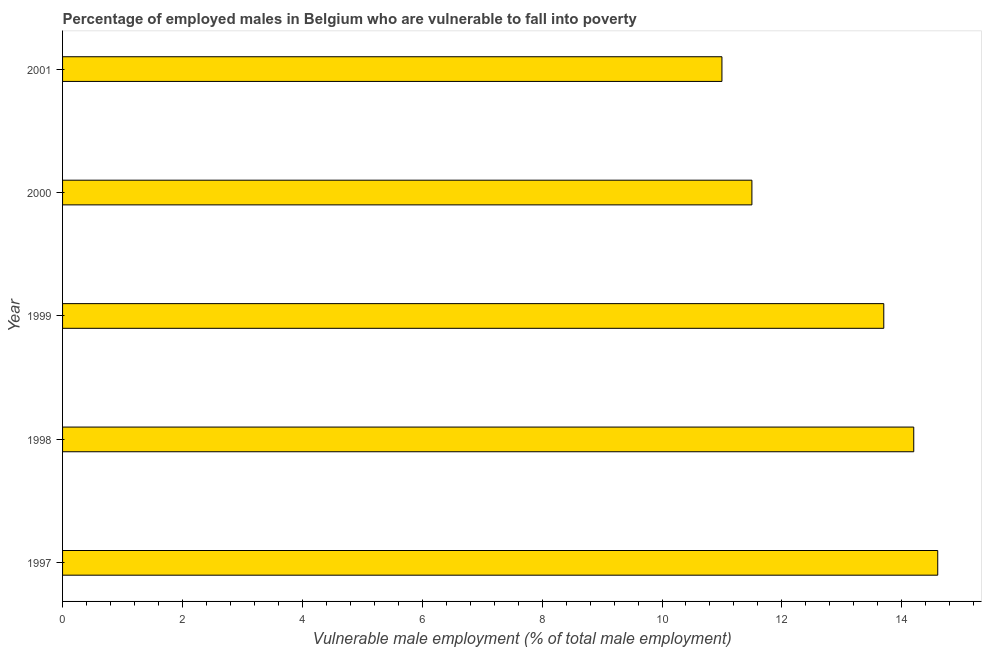Does the graph contain any zero values?
Your answer should be very brief. No. What is the title of the graph?
Your answer should be very brief. Percentage of employed males in Belgium who are vulnerable to fall into poverty. What is the label or title of the X-axis?
Provide a short and direct response. Vulnerable male employment (% of total male employment). What is the label or title of the Y-axis?
Provide a short and direct response. Year. What is the percentage of employed males who are vulnerable to fall into poverty in 2001?
Give a very brief answer. 11. Across all years, what is the maximum percentage of employed males who are vulnerable to fall into poverty?
Make the answer very short. 14.6. In which year was the percentage of employed males who are vulnerable to fall into poverty minimum?
Ensure brevity in your answer.  2001. What is the sum of the percentage of employed males who are vulnerable to fall into poverty?
Your answer should be very brief. 65. What is the difference between the percentage of employed males who are vulnerable to fall into poverty in 2000 and 2001?
Provide a short and direct response. 0.5. What is the average percentage of employed males who are vulnerable to fall into poverty per year?
Provide a succinct answer. 13. What is the median percentage of employed males who are vulnerable to fall into poverty?
Your response must be concise. 13.7. In how many years, is the percentage of employed males who are vulnerable to fall into poverty greater than 8 %?
Your answer should be very brief. 5. What is the ratio of the percentage of employed males who are vulnerable to fall into poverty in 1997 to that in 1999?
Give a very brief answer. 1.07. Is the difference between the percentage of employed males who are vulnerable to fall into poverty in 1998 and 1999 greater than the difference between any two years?
Keep it short and to the point. No. What is the difference between the highest and the second highest percentage of employed males who are vulnerable to fall into poverty?
Offer a very short reply. 0.4. Is the sum of the percentage of employed males who are vulnerable to fall into poverty in 1997 and 2000 greater than the maximum percentage of employed males who are vulnerable to fall into poverty across all years?
Make the answer very short. Yes. In how many years, is the percentage of employed males who are vulnerable to fall into poverty greater than the average percentage of employed males who are vulnerable to fall into poverty taken over all years?
Your answer should be very brief. 3. Are all the bars in the graph horizontal?
Provide a short and direct response. Yes. What is the Vulnerable male employment (% of total male employment) of 1997?
Your answer should be very brief. 14.6. What is the Vulnerable male employment (% of total male employment) in 1998?
Your answer should be very brief. 14.2. What is the Vulnerable male employment (% of total male employment) in 1999?
Offer a terse response. 13.7. What is the Vulnerable male employment (% of total male employment) of 2000?
Keep it short and to the point. 11.5. What is the Vulnerable male employment (% of total male employment) in 2001?
Ensure brevity in your answer.  11. What is the difference between the Vulnerable male employment (% of total male employment) in 1997 and 1998?
Offer a very short reply. 0.4. What is the difference between the Vulnerable male employment (% of total male employment) in 1997 and 2000?
Provide a short and direct response. 3.1. What is the difference between the Vulnerable male employment (% of total male employment) in 1998 and 2000?
Offer a very short reply. 2.7. What is the difference between the Vulnerable male employment (% of total male employment) in 1999 and 2000?
Provide a succinct answer. 2.2. What is the difference between the Vulnerable male employment (% of total male employment) in 1999 and 2001?
Provide a succinct answer. 2.7. What is the ratio of the Vulnerable male employment (% of total male employment) in 1997 to that in 1998?
Give a very brief answer. 1.03. What is the ratio of the Vulnerable male employment (% of total male employment) in 1997 to that in 1999?
Make the answer very short. 1.07. What is the ratio of the Vulnerable male employment (% of total male employment) in 1997 to that in 2000?
Ensure brevity in your answer.  1.27. What is the ratio of the Vulnerable male employment (% of total male employment) in 1997 to that in 2001?
Your answer should be compact. 1.33. What is the ratio of the Vulnerable male employment (% of total male employment) in 1998 to that in 1999?
Offer a very short reply. 1.04. What is the ratio of the Vulnerable male employment (% of total male employment) in 1998 to that in 2000?
Your answer should be compact. 1.24. What is the ratio of the Vulnerable male employment (% of total male employment) in 1998 to that in 2001?
Your response must be concise. 1.29. What is the ratio of the Vulnerable male employment (% of total male employment) in 1999 to that in 2000?
Ensure brevity in your answer.  1.19. What is the ratio of the Vulnerable male employment (% of total male employment) in 1999 to that in 2001?
Provide a short and direct response. 1.25. What is the ratio of the Vulnerable male employment (% of total male employment) in 2000 to that in 2001?
Offer a very short reply. 1.04. 